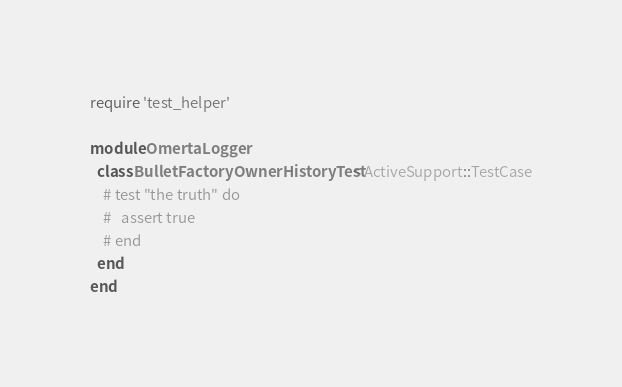Convert code to text. <code><loc_0><loc_0><loc_500><loc_500><_Ruby_>require 'test_helper'

module OmertaLogger
  class BulletFactoryOwnerHistoryTest < ActiveSupport::TestCase
    # test "the truth" do
    #   assert true
    # end
  end
end
</code> 